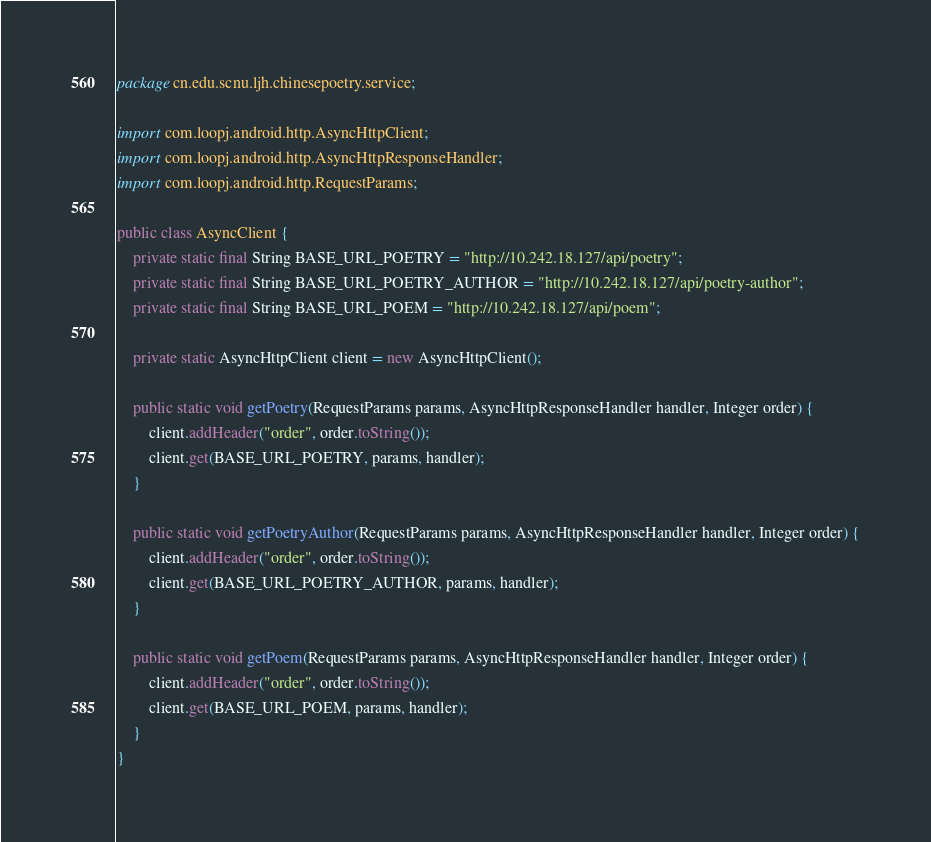<code> <loc_0><loc_0><loc_500><loc_500><_Java_>package cn.edu.scnu.ljh.chinesepoetry.service;

import com.loopj.android.http.AsyncHttpClient;
import com.loopj.android.http.AsyncHttpResponseHandler;
import com.loopj.android.http.RequestParams;

public class AsyncClient {
    private static final String BASE_URL_POETRY = "http://10.242.18.127/api/poetry";
    private static final String BASE_URL_POETRY_AUTHOR = "http://10.242.18.127/api/poetry-author";
    private static final String BASE_URL_POEM = "http://10.242.18.127/api/poem";

    private static AsyncHttpClient client = new AsyncHttpClient();

    public static void getPoetry(RequestParams params, AsyncHttpResponseHandler handler, Integer order) {
        client.addHeader("order", order.toString());
        client.get(BASE_URL_POETRY, params, handler);
    }

    public static void getPoetryAuthor(RequestParams params, AsyncHttpResponseHandler handler, Integer order) {
        client.addHeader("order", order.toString());
        client.get(BASE_URL_POETRY_AUTHOR, params, handler);
    }

    public static void getPoem(RequestParams params, AsyncHttpResponseHandler handler, Integer order) {
        client.addHeader("order", order.toString());
        client.get(BASE_URL_POEM, params, handler);
    }
}
</code> 